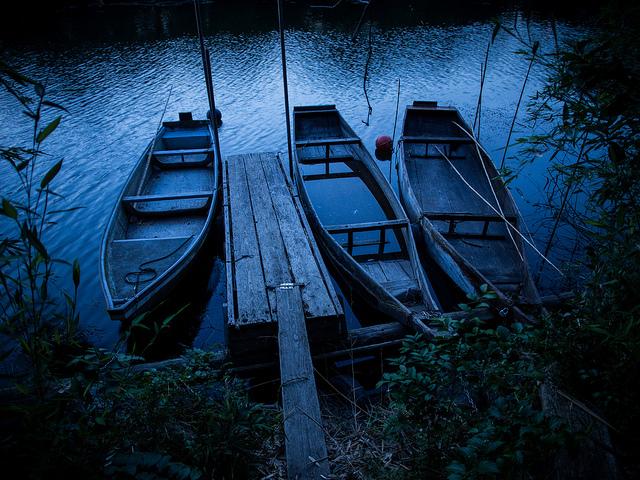What time is it?
Concise answer only. Night. Which boat has water in the bottom?
Give a very brief answer. Middle. How many boats are there?
Give a very brief answer. 3. 